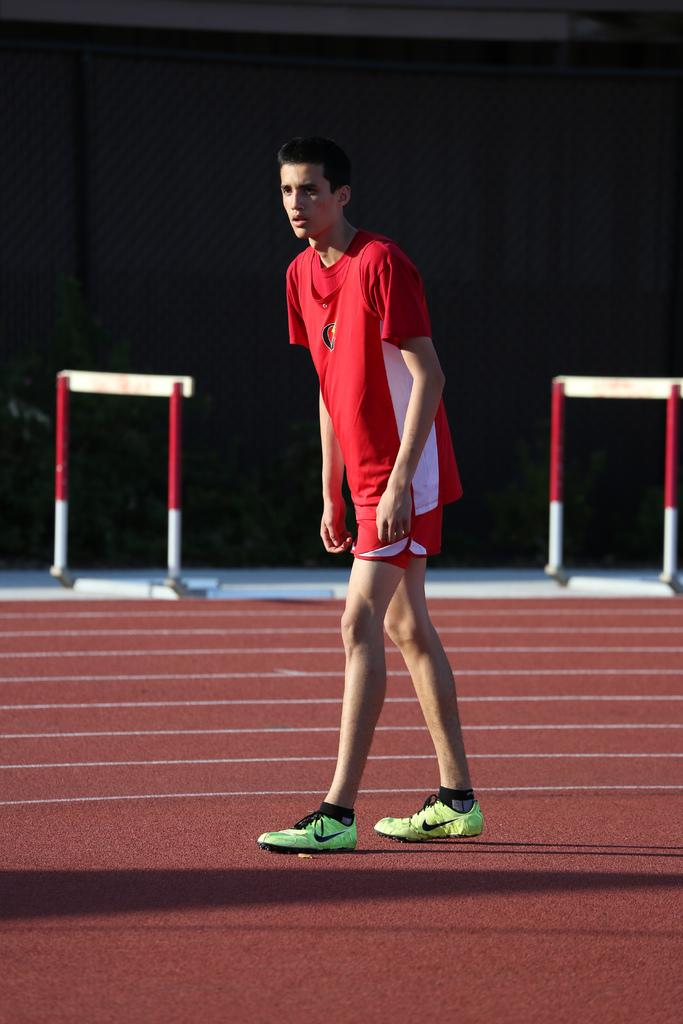What is the main subject of subject in the image? There is a man standing in the image. What can be seen beneath the man's feet? The ground is visible in the image. What is present in the background of the image? There are boards on poles, plants, and a wall in the background of the image. What type of crayon is the man using to draw on the wall in the image? A: There is no crayon or drawing activity present in the image. Can you tell me how many goats are visible in the image? There are no goats present in the image. 